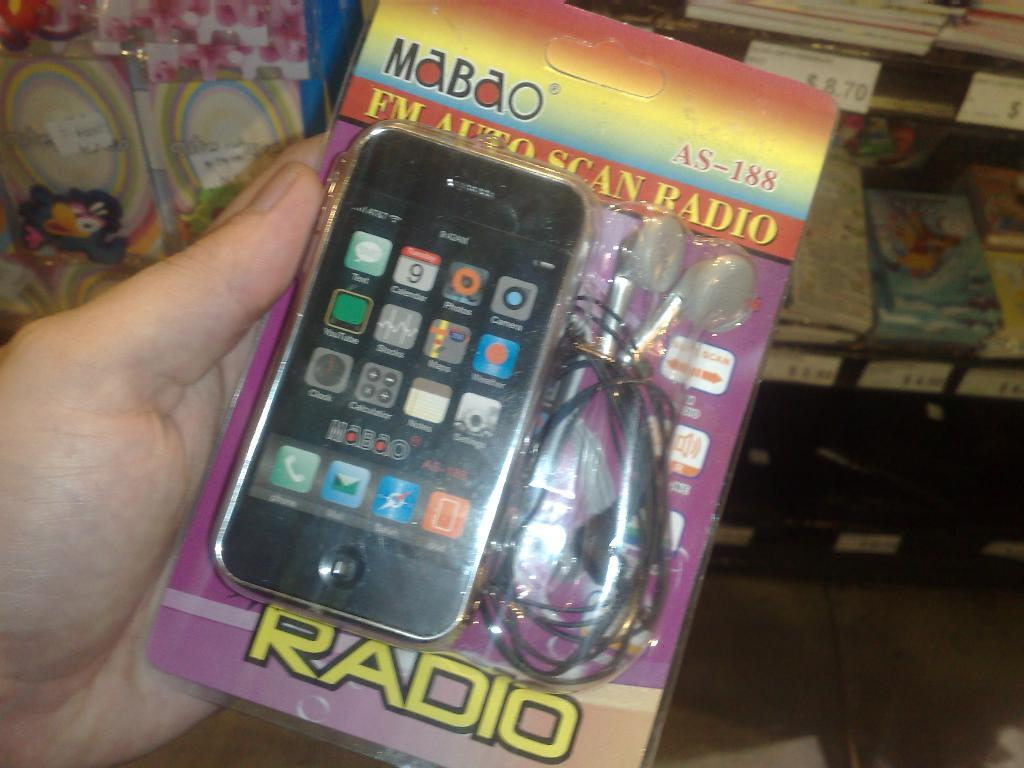What is the person's hand holding in the image? There is a person's hand holding an object in the image. What type of storage can be seen in the image? There are objects in racks in the image. How can the price of the objects be identified in the image? Price stickers are present in the image. What type of linen is being used to cover the objects in the image? There is no linen present in the image; the objects are in racks without any covering. What type of alarm is going off in the image? There is no alarm present in the image; it is a still image without any sound or indication of an alarm. 